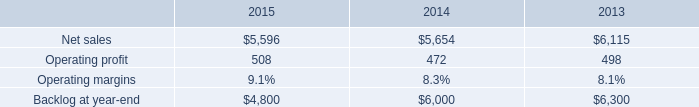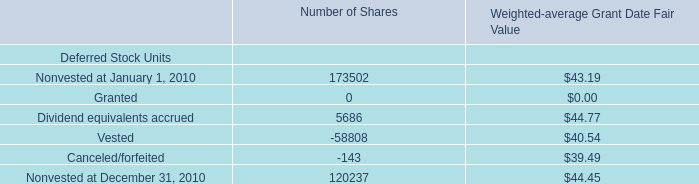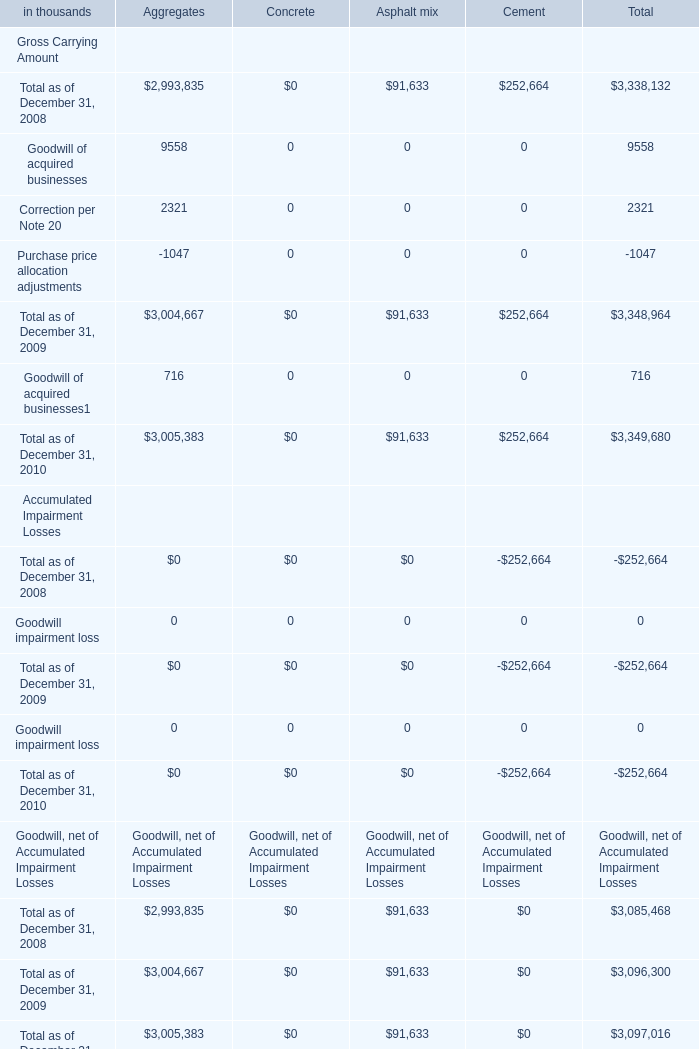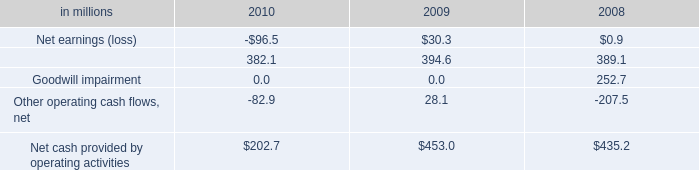What is the ratio of Total as of December 31, 2010 to the total in 2010 for Asphalt mix? 
Computations: (91633 / (716 + 3349680))
Answer: 0.02735. 